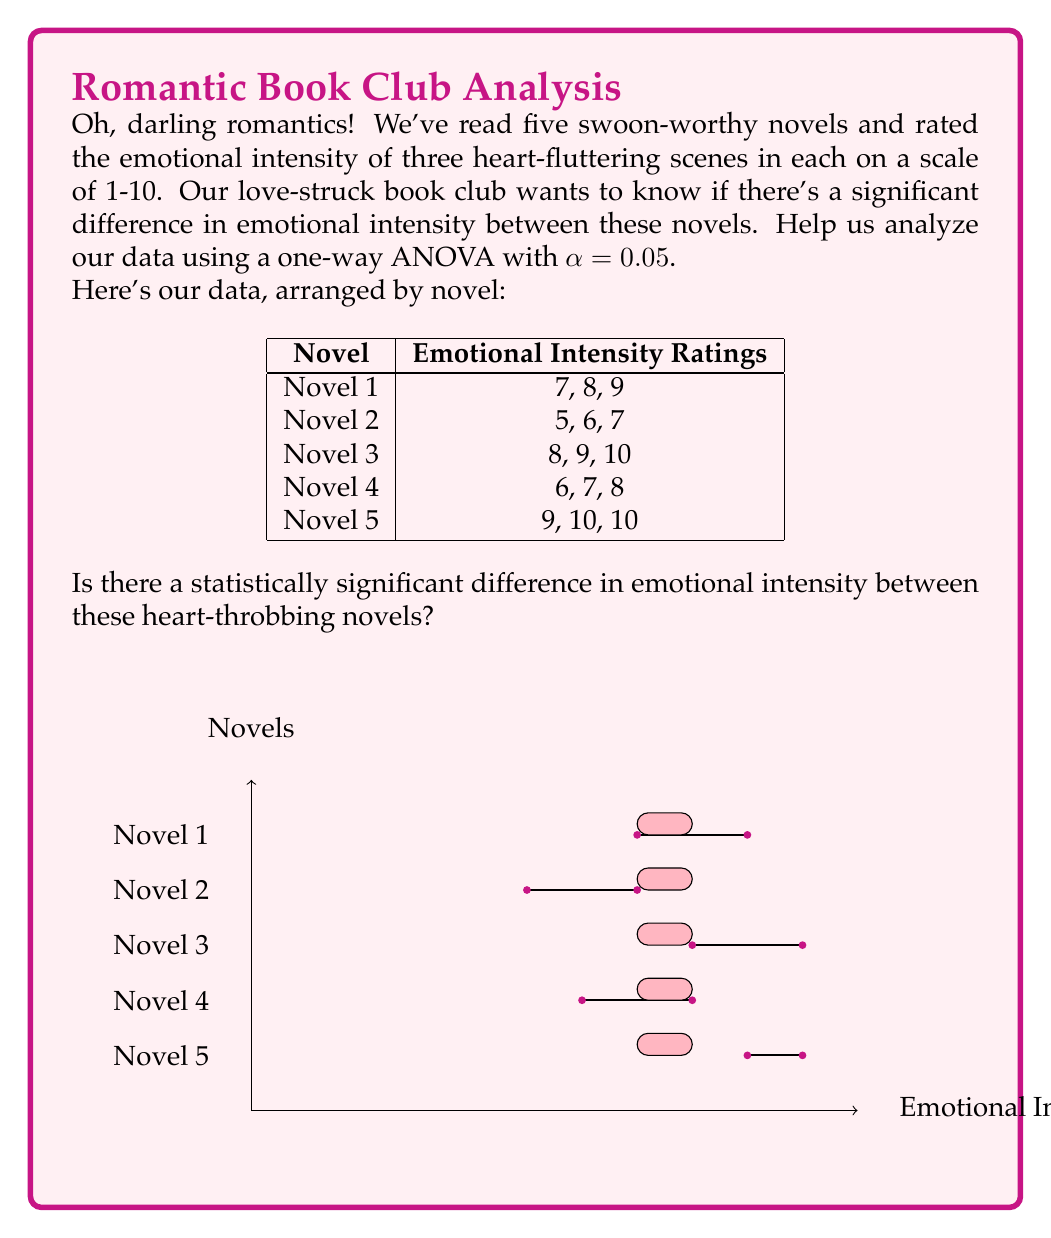What is the answer to this math problem? Let's analyze this romantic data with a one-way ANOVA, step by step:

1) First, we need to calculate the following:
   - Grand mean
   - Sum of squares total (SST)
   - Sum of squares between groups (SSB)
   - Sum of squares within groups (SSW)
   - Degrees of freedom (df)
   - Mean squares
   - F-statistic

2) Calculate the grand mean:
   $\bar{X} = \frac{7+8+9+5+6+7+8+9+10+6+7+8+9+10+10}{15} = 7.93$

3) Calculate SST:
   $SST = \sum(X - \bar{X})^2 = (7-7.93)^2 + (8-7.93)^2 + ... + (10-7.93)^2 = 40.93$

4) Calculate SSB:
   $SSB = \sum n_i(\bar{X_i} - \bar{X})^2$
   Where $n_i$ is the number of observations in each group (3 for each novel)
   $SSB = 3[(8-7.93)^2 + (6-7.93)^2 + (9-7.93)^2 + (7-7.93)^2 + (9.67-7.93)^2] = 30.93$

5) Calculate SSW:
   $SSW = SST - SSB = 40.93 - 30.93 = 10$

6) Degrees of freedom:
   $df_{between} = k - 1 = 5 - 1 = 4$ (where k is the number of groups)
   $df_{within} = N - k = 15 - 5 = 10$ (where N is the total number of observations)

7) Calculate mean squares:
   $MS_{between} = \frac{SSB}{df_{between}} = \frac{30.93}{4} = 7.73$
   $MS_{within} = \frac{SSW}{df_{within}} = \frac{10}{10} = 1$

8) Calculate F-statistic:
   $F = \frac{MS_{between}}{MS_{within}} = \frac{7.73}{1} = 7.73$

9) Find the critical F-value:
   With $df_{between} = 4$ and $df_{within} = 10$, and α = 0.05
   $F_{critical} = 3.48$ (from F-distribution table)

10) Compare F-statistic to F-critical:
    Since $7.73 > 3.48$, we reject the null hypothesis.

Therefore, there is a statistically significant difference in emotional intensity between these novels at the 0.05 significance level.
Answer: $F(4,10) = 7.73, p < 0.05$. Significant difference exists. 